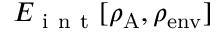<formula> <loc_0><loc_0><loc_500><loc_500>E _ { i n t } [ \rho _ { A } , \rho _ { e n v } ]</formula> 